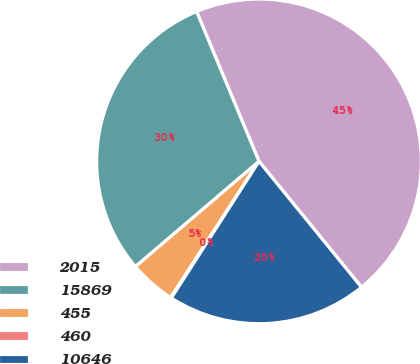Convert chart. <chart><loc_0><loc_0><loc_500><loc_500><pie_chart><fcel>2015<fcel>15869<fcel>455<fcel>460<fcel>10646<nl><fcel>45.4%<fcel>29.95%<fcel>4.61%<fcel>0.08%<fcel>19.95%<nl></chart> 